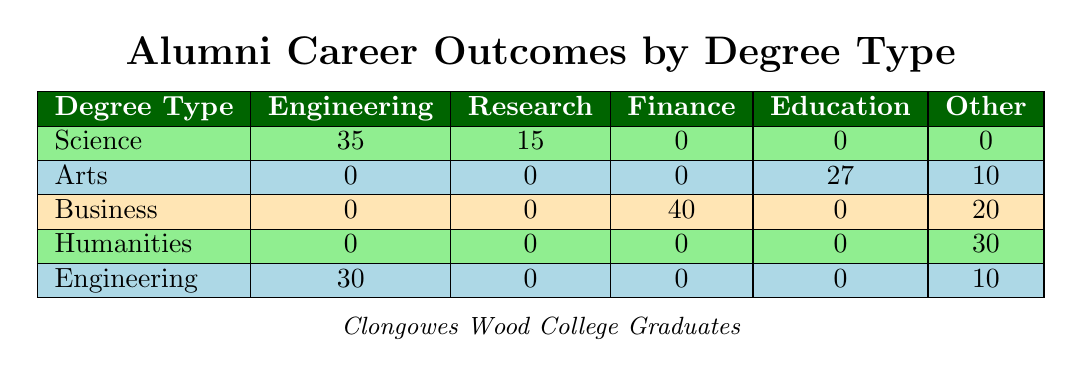What is the count of alumni pursuing Engineering from a Science degree? In the table under the Science row, the column for Engineering has a count of 35.
Answer: 35 Which degree type has the highest count of graduates in Finance? In the table, only the Business row has a count of 40 in the Finance column, which is the highest among all rows.
Answer: Business How many alumni from the Arts degree pursue careers classified as Other? In the Arts row, the count of Other careers is found in the Publishing column which has a count of 10.
Answer: 10 What is the total number of alumni pursuing a career in Research across all degree types? To find the total for Research, we look at the Science (15) and Engineering (30) rows. Adding these gives 15 + 0 + 0 + 0 + 0 + 30 = 45.
Answer: 45 Is it true that more alumni from Business than from Humanities are involved in Finance? The table shows 40 for Business in Finance and 0 for Humanities; thus, it is true that more alumni from Business are involved in Finance.
Answer: Yes Which degree type has the lowest total count of alumni entering the NGO sector, and what is that count? The Humanities row has the only mention of NGO with a count of 5, which is the lowest since all other rows have 0. Thus, Humanities has the lowest count of 5.
Answer: Humanities, 5 What is the difference in the number of alumni pursuing Engineering from Science and Engineering degrees? The count for Engineering (Science) is 35 and for Engineering (Engineering) is 30. The difference is 35 - 30 = 5.
Answer: 5 How many alumni from the Humanities degree are involved in any career path listed? The Humanities row indicates counts of 25 (Public Sector) and 5 (NGO), totaling 30.
Answer: 30 Does the data suggest that more students choose entrepreneurial paths under Business than those pursuing Research under Engineering? Business has 20 in Entrepreneurship, while Engineering shows 0 in Research. Thus, it suggests more students choose entrepreneurial paths in Business.
Answer: Yes 